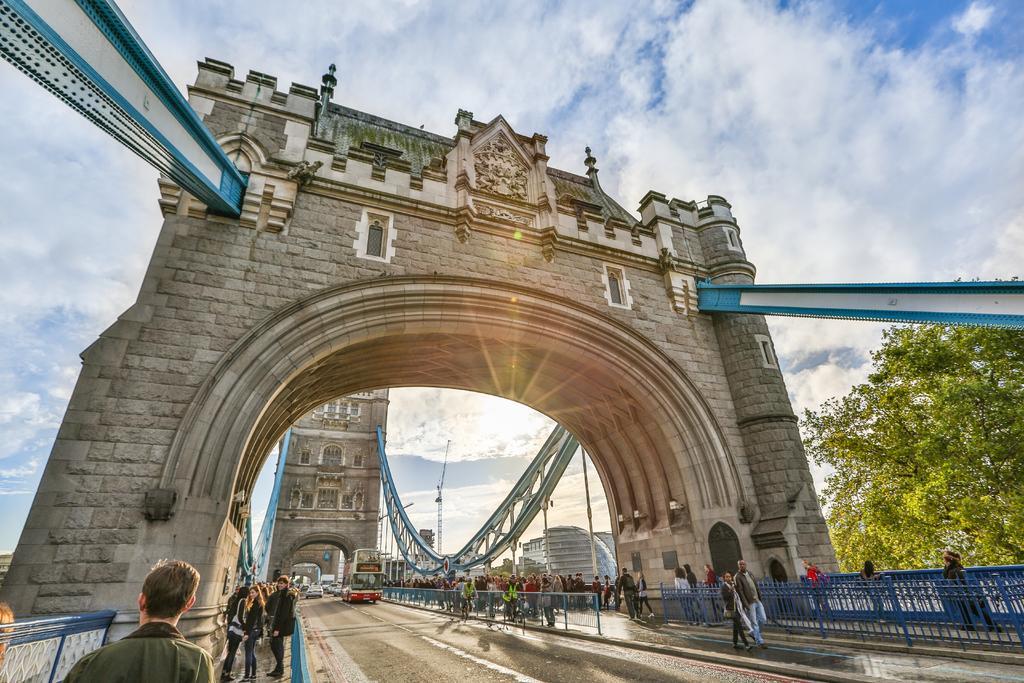Can you describe this image briefly? The picture consists of hanging bridge. In the foreground of the picture it is road, on the road there are vehicles and lot of people walking down the road. In the background it is sky, in the center of the sky it is sun. On the right there is a tree. In the center of the picture we can see arches on the bridge. 